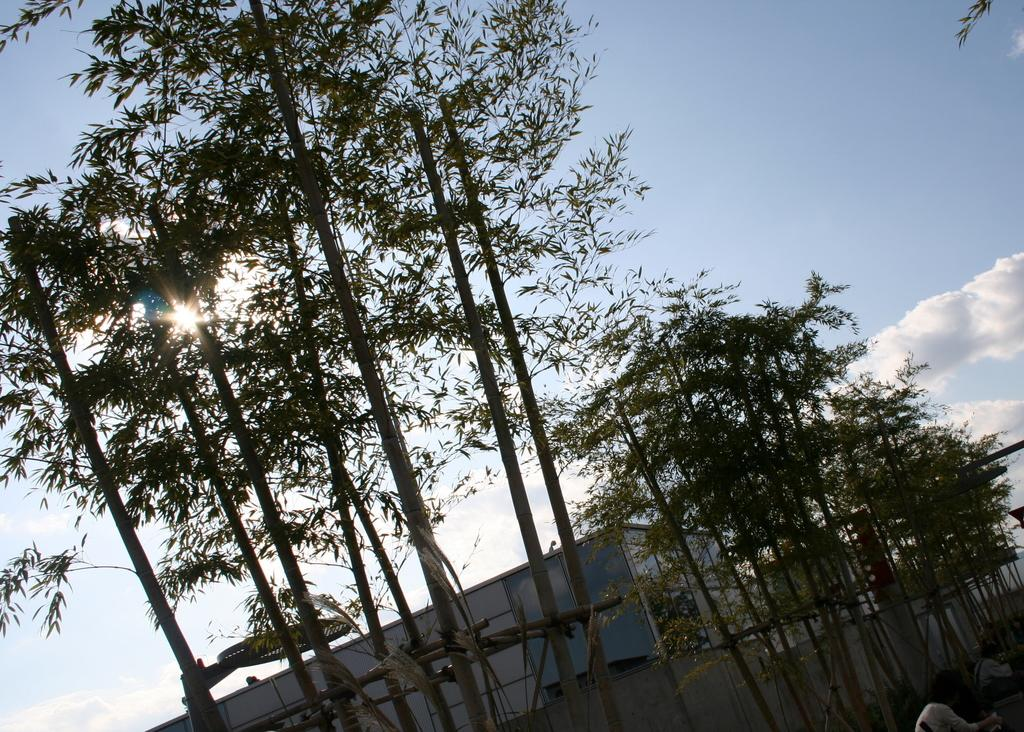What type of vegetation is visible in the image? There are trees in front of the image. Where are the people located in the image? The people are on the right side of the image. What type of structures can be seen in the background of the image? There are buildings in the background of the image. What is visible in the sky in the image? The sky is visible in the background of the image. What book is the person reading in the image? There is no person reading a book in the image; the people are simply located on the right side of the image. What type of picture is hanging on the wall in the image? There is no picture hanging on the wall in the image; the image only shows trees, people, buildings, and the sky. 